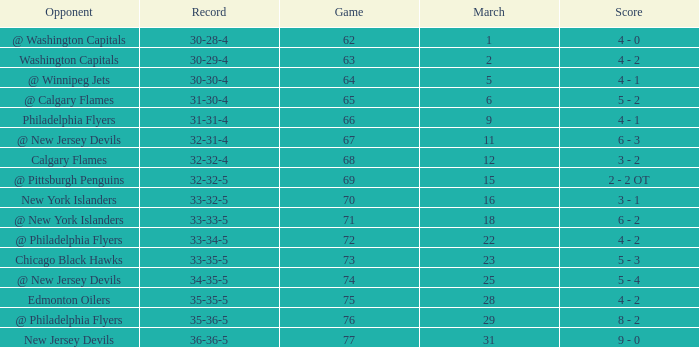How many games ended in a record of 30-28-4, with a March more than 1? 0.0. 